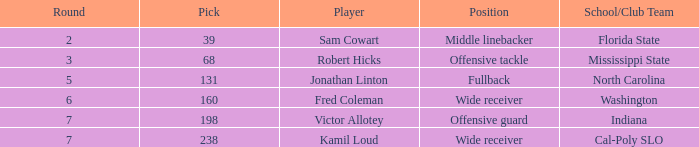In which round can a team from a north carolina school/club be found with a pick larger than 131? 0.0. 